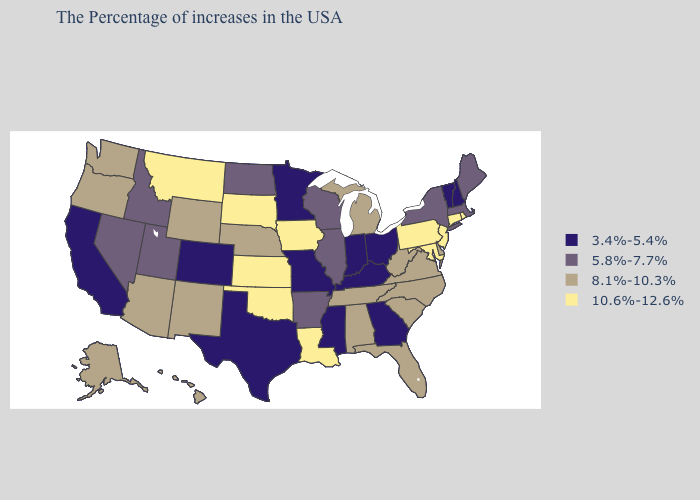What is the highest value in the South ?
Be succinct. 10.6%-12.6%. What is the highest value in the West ?
Short answer required. 10.6%-12.6%. Among the states that border Nebraska , which have the highest value?
Quick response, please. Iowa, Kansas, South Dakota. Name the states that have a value in the range 10.6%-12.6%?
Write a very short answer. Rhode Island, Connecticut, New Jersey, Maryland, Pennsylvania, Louisiana, Iowa, Kansas, Oklahoma, South Dakota, Montana. Does the first symbol in the legend represent the smallest category?
Keep it brief. Yes. Does the first symbol in the legend represent the smallest category?
Keep it brief. Yes. Name the states that have a value in the range 5.8%-7.7%?
Short answer required. Maine, Massachusetts, New York, Wisconsin, Illinois, Arkansas, North Dakota, Utah, Idaho, Nevada. What is the value of Oklahoma?
Give a very brief answer. 10.6%-12.6%. Name the states that have a value in the range 8.1%-10.3%?
Give a very brief answer. Delaware, Virginia, North Carolina, South Carolina, West Virginia, Florida, Michigan, Alabama, Tennessee, Nebraska, Wyoming, New Mexico, Arizona, Washington, Oregon, Alaska, Hawaii. Which states hav the highest value in the Northeast?
Be succinct. Rhode Island, Connecticut, New Jersey, Pennsylvania. Does Kansas have the highest value in the MidWest?
Short answer required. Yes. Does the map have missing data?
Write a very short answer. No. Among the states that border Rhode Island , does Connecticut have the highest value?
Give a very brief answer. Yes. Name the states that have a value in the range 8.1%-10.3%?
Quick response, please. Delaware, Virginia, North Carolina, South Carolina, West Virginia, Florida, Michigan, Alabama, Tennessee, Nebraska, Wyoming, New Mexico, Arizona, Washington, Oregon, Alaska, Hawaii. Name the states that have a value in the range 10.6%-12.6%?
Concise answer only. Rhode Island, Connecticut, New Jersey, Maryland, Pennsylvania, Louisiana, Iowa, Kansas, Oklahoma, South Dakota, Montana. 